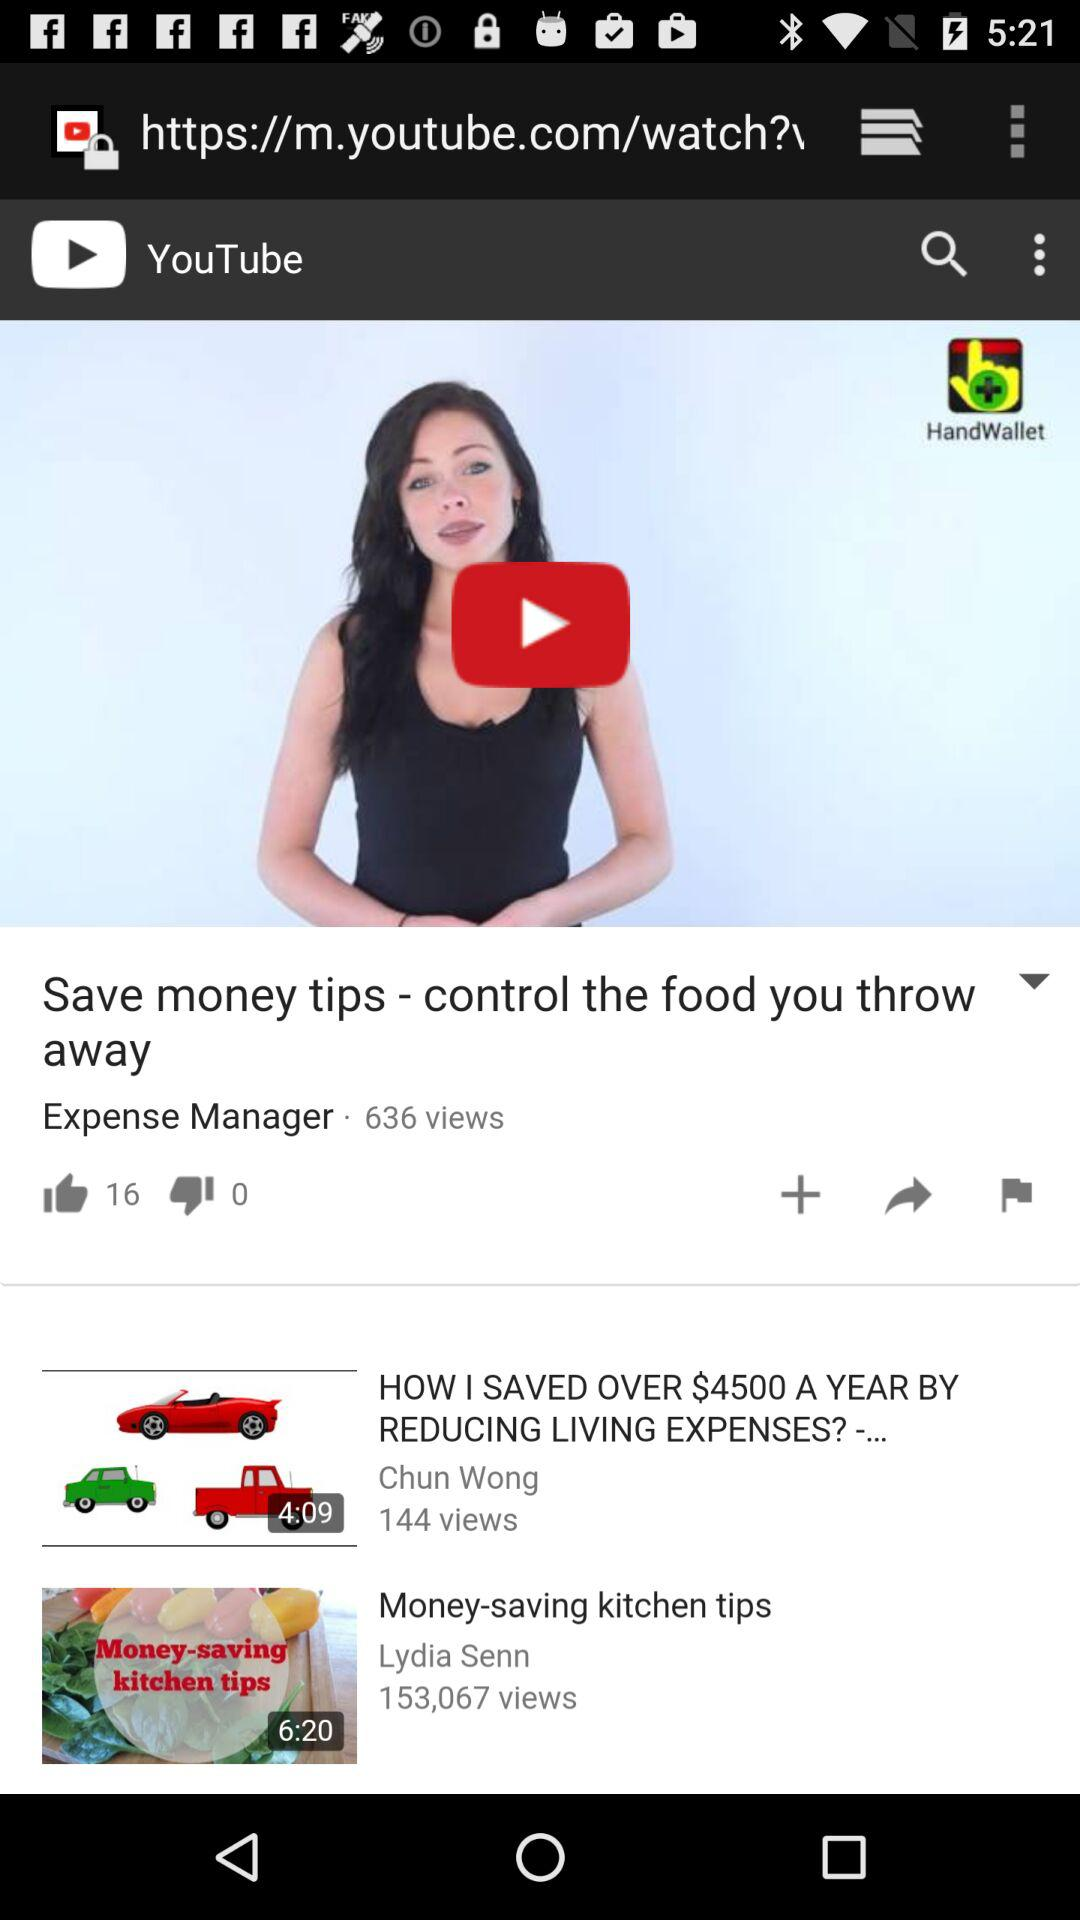How many likes did the "Save money tips" video get? "Save money tips" video got 16 likes. 